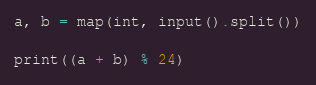<code> <loc_0><loc_0><loc_500><loc_500><_Python_>a, b = map(int, input().split())

print((a + b) % 24)
</code> 